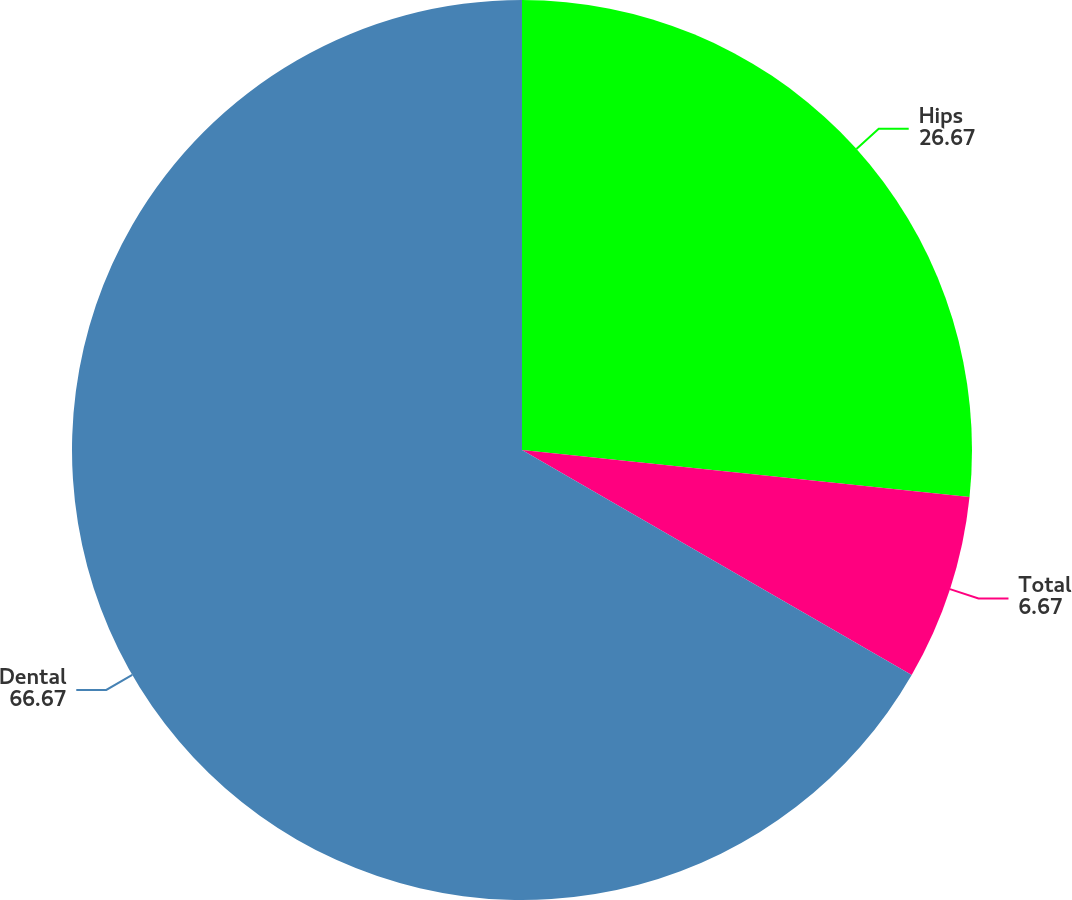Convert chart. <chart><loc_0><loc_0><loc_500><loc_500><pie_chart><fcel>Hips<fcel>Total<fcel>Dental<nl><fcel>26.67%<fcel>6.67%<fcel>66.67%<nl></chart> 